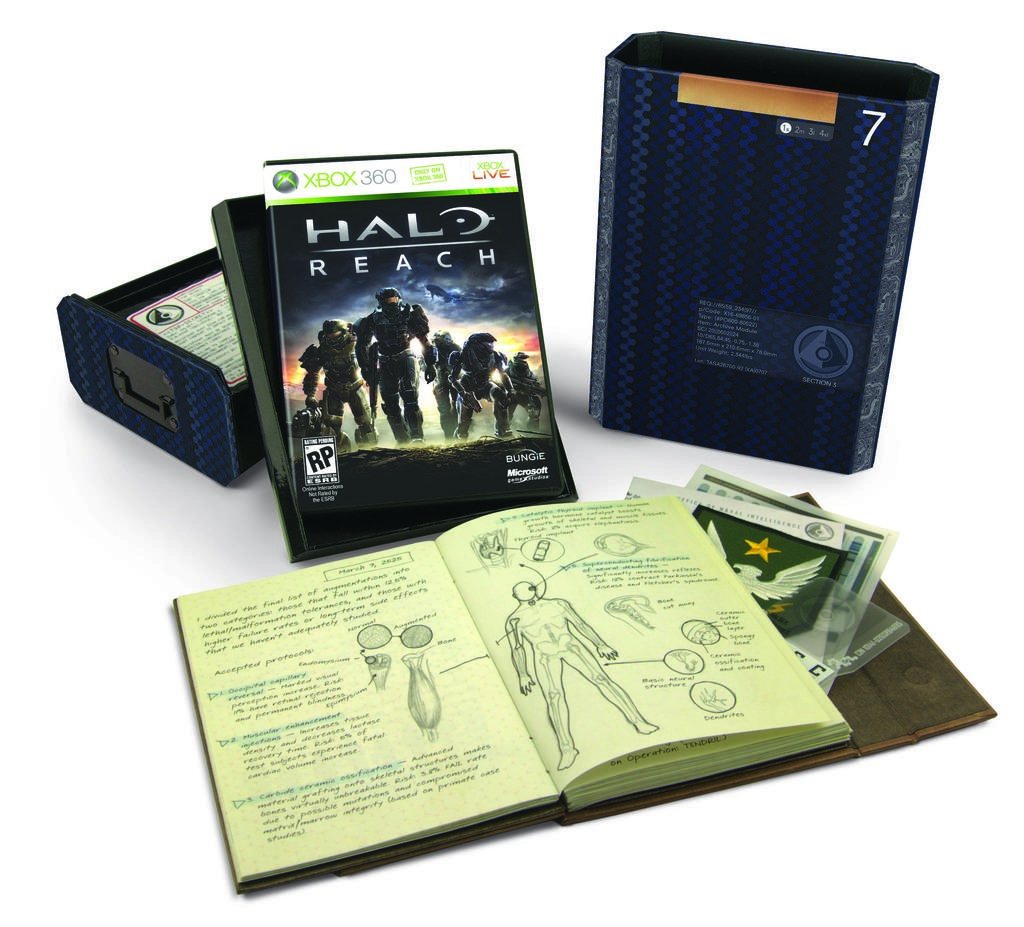What is the platform the game is for?
Give a very brief answer. Xbox 360. What game is this?
Your answer should be compact. Halo reach. 